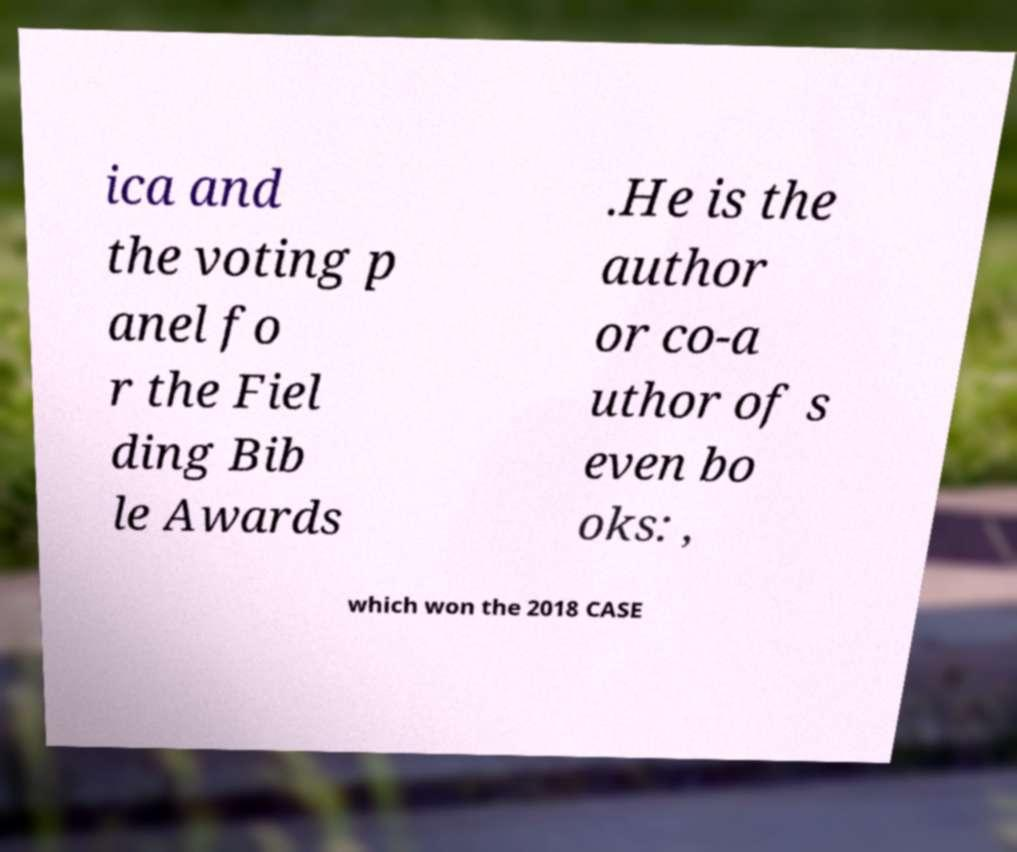Could you assist in decoding the text presented in this image and type it out clearly? ica and the voting p anel fo r the Fiel ding Bib le Awards .He is the author or co-a uthor of s even bo oks: , which won the 2018 CASE 